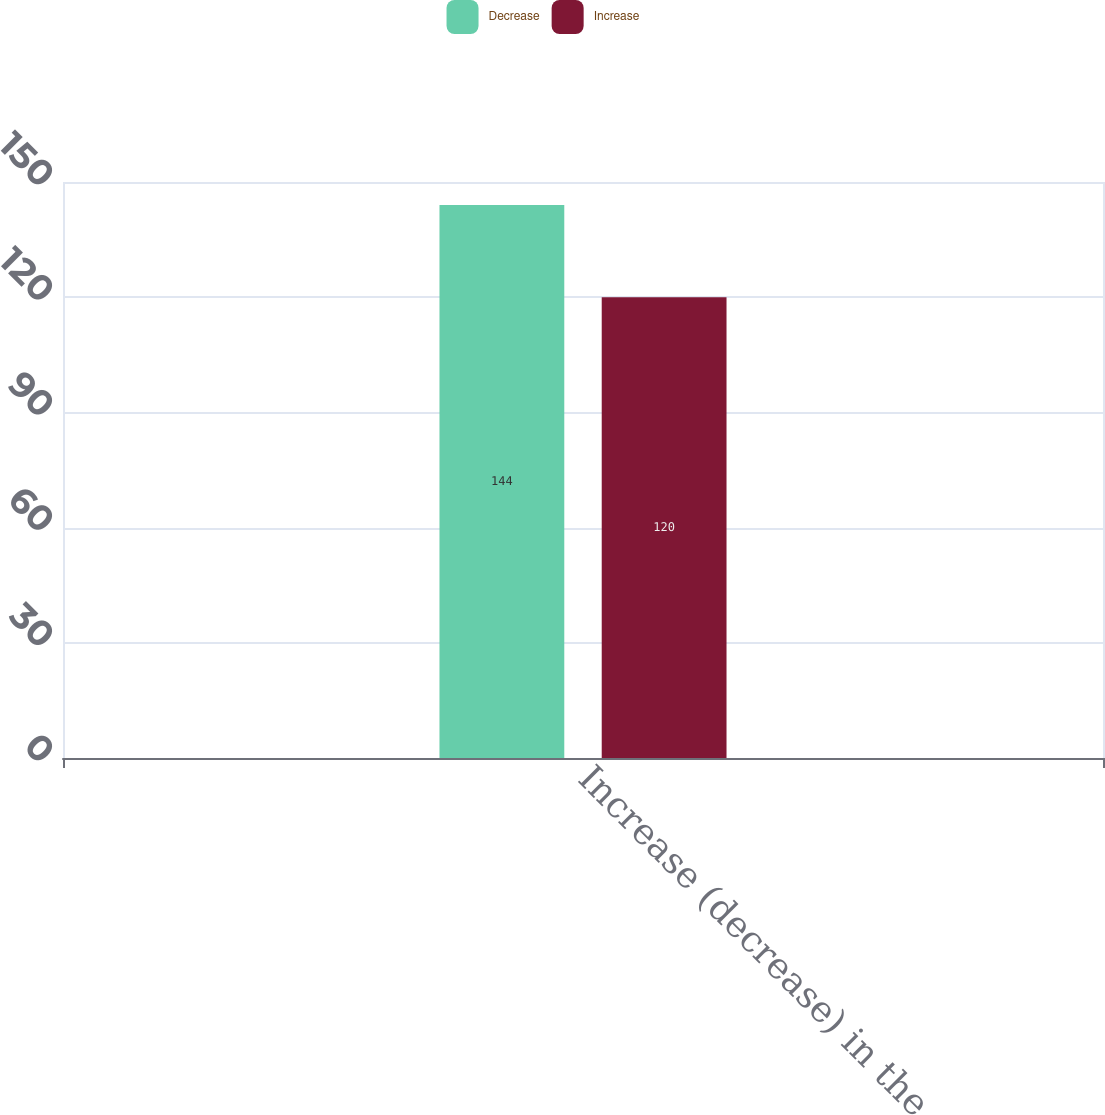Convert chart. <chart><loc_0><loc_0><loc_500><loc_500><stacked_bar_chart><ecel><fcel>Increase (decrease) in the<nl><fcel>Decrease<fcel>144<nl><fcel>Increase<fcel>120<nl></chart> 